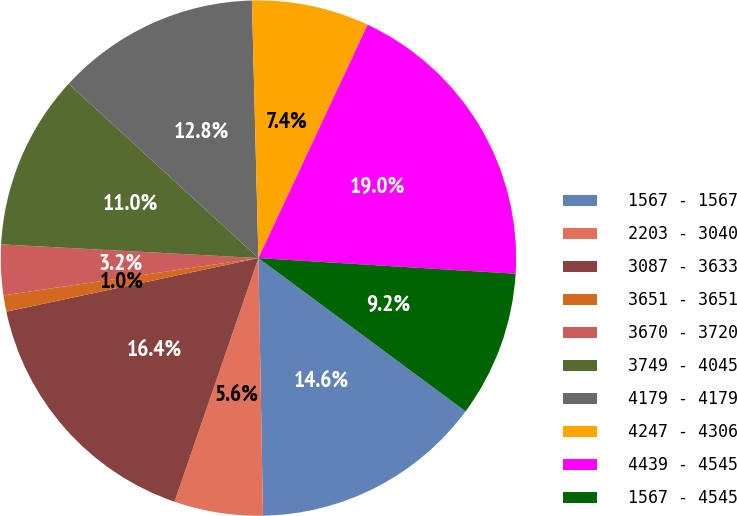Convert chart to OTSL. <chart><loc_0><loc_0><loc_500><loc_500><pie_chart><fcel>1567 - 1567<fcel>2203 - 3040<fcel>3087 - 3633<fcel>3651 - 3651<fcel>3670 - 3720<fcel>3749 - 4045<fcel>4179 - 4179<fcel>4247 - 4306<fcel>4439 - 4545<fcel>1567 - 4545<nl><fcel>14.58%<fcel>5.56%<fcel>16.39%<fcel>1.02%<fcel>3.16%<fcel>10.97%<fcel>12.78%<fcel>7.37%<fcel>19.0%<fcel>9.17%<nl></chart> 